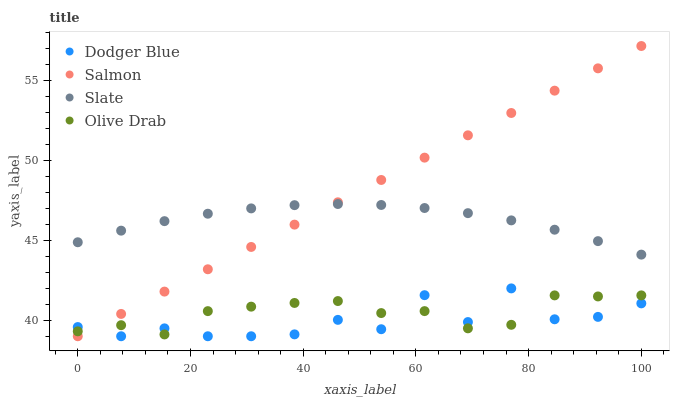Does Dodger Blue have the minimum area under the curve?
Answer yes or no. Yes. Does Salmon have the maximum area under the curve?
Answer yes or no. Yes. Does Slate have the minimum area under the curve?
Answer yes or no. No. Does Slate have the maximum area under the curve?
Answer yes or no. No. Is Salmon the smoothest?
Answer yes or no. Yes. Is Dodger Blue the roughest?
Answer yes or no. Yes. Is Slate the smoothest?
Answer yes or no. No. Is Slate the roughest?
Answer yes or no. No. Does Salmon have the lowest value?
Answer yes or no. Yes. Does Slate have the lowest value?
Answer yes or no. No. Does Salmon have the highest value?
Answer yes or no. Yes. Does Slate have the highest value?
Answer yes or no. No. Is Olive Drab less than Slate?
Answer yes or no. Yes. Is Slate greater than Dodger Blue?
Answer yes or no. Yes. Does Dodger Blue intersect Olive Drab?
Answer yes or no. Yes. Is Dodger Blue less than Olive Drab?
Answer yes or no. No. Is Dodger Blue greater than Olive Drab?
Answer yes or no. No. Does Olive Drab intersect Slate?
Answer yes or no. No. 